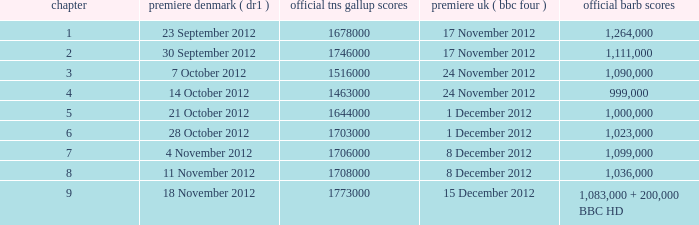What is the BARB ratings of episode 6? 1023000.0. 